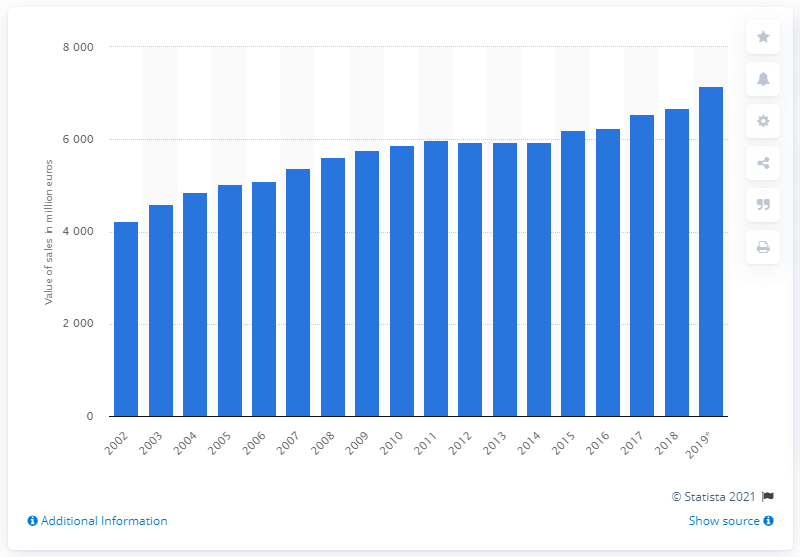Mention a couple of crucial points in this snapshot. Pharmaceutical sales in Belgium were valued at 7,145.5 million euros from 2002 to 2019. 